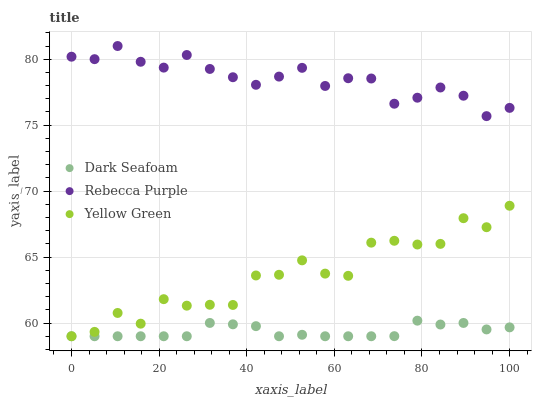Does Dark Seafoam have the minimum area under the curve?
Answer yes or no. Yes. Does Rebecca Purple have the maximum area under the curve?
Answer yes or no. Yes. Does Yellow Green have the minimum area under the curve?
Answer yes or no. No. Does Yellow Green have the maximum area under the curve?
Answer yes or no. No. Is Dark Seafoam the smoothest?
Answer yes or no. Yes. Is Yellow Green the roughest?
Answer yes or no. Yes. Is Rebecca Purple the smoothest?
Answer yes or no. No. Is Rebecca Purple the roughest?
Answer yes or no. No. Does Dark Seafoam have the lowest value?
Answer yes or no. Yes. Does Rebecca Purple have the lowest value?
Answer yes or no. No. Does Rebecca Purple have the highest value?
Answer yes or no. Yes. Does Yellow Green have the highest value?
Answer yes or no. No. Is Yellow Green less than Rebecca Purple?
Answer yes or no. Yes. Is Rebecca Purple greater than Dark Seafoam?
Answer yes or no. Yes. Does Dark Seafoam intersect Yellow Green?
Answer yes or no. Yes. Is Dark Seafoam less than Yellow Green?
Answer yes or no. No. Is Dark Seafoam greater than Yellow Green?
Answer yes or no. No. Does Yellow Green intersect Rebecca Purple?
Answer yes or no. No. 